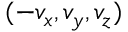Convert formula to latex. <formula><loc_0><loc_0><loc_500><loc_500>( - v _ { x } , v _ { y } , v _ { z } )</formula> 